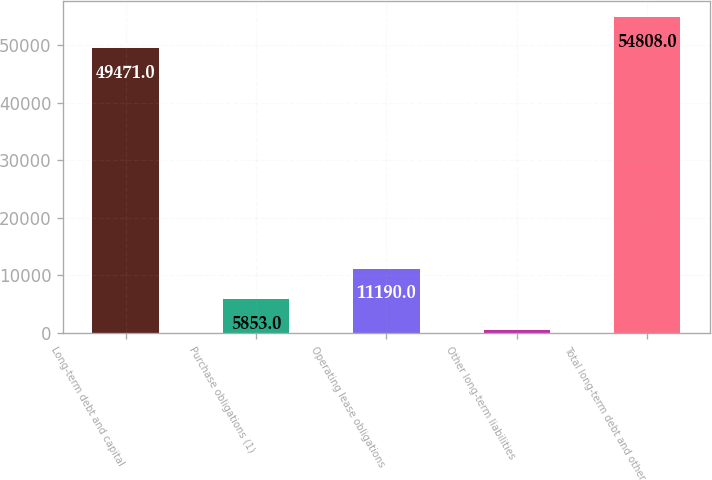Convert chart to OTSL. <chart><loc_0><loc_0><loc_500><loc_500><bar_chart><fcel>Long-term debt and capital<fcel>Purchase obligations (1)<fcel>Operating lease obligations<fcel>Other long-term liabilities<fcel>Total long-term debt and other<nl><fcel>49471<fcel>5853<fcel>11190<fcel>516<fcel>54808<nl></chart> 